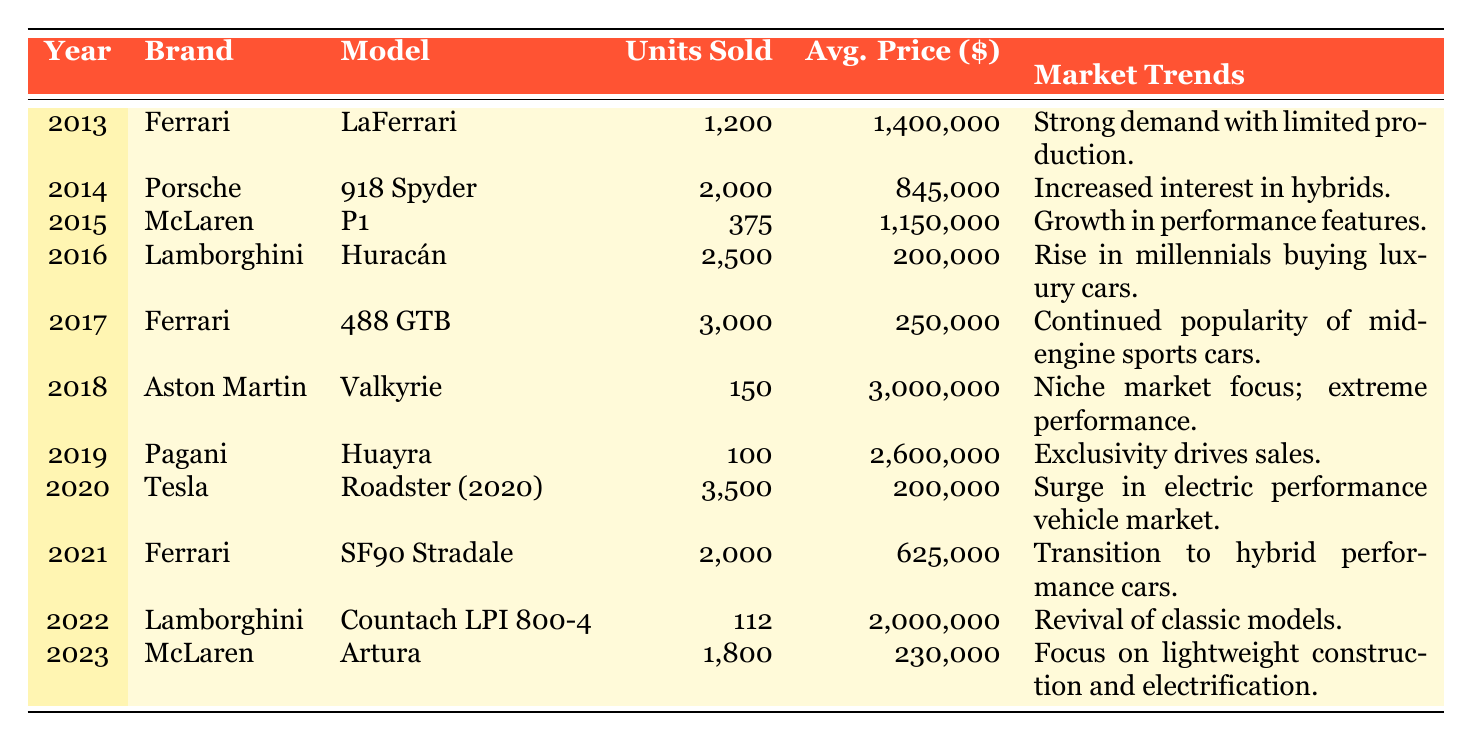What was the highest average price for a luxury sports car in the table? The highest average price is found in the row for the Aston Martin Valkyrie with an average price of 3,000,000. This can be confirmed by checking all average prices listed for each model.
Answer: 3,000,000 In which year did Ferrari sell the most units? Ferrari sold the most units in 2017 with 3,000 units sold for the 488 GTB model. We can find this by comparing the units sold for all Ferrari models listed in the table.
Answer: 2017 What is the total number of luxury sports cars sold by Lamborghini over the years listed? The total units sold by Lamborghini is 2,500 (Huracán in 2016) + 112 (Countach LPI 800-4 in 2022) = 2,612. We sum the units sold for both Lamborghini models to get the total.
Answer: 2,612 Did Tesla sell more units than Pagani in 2020 and 2019 combined? In 2020, Tesla sold 3,500 units (Roadster), while Pagani sold 100 units in 2019 (Huayra). Combining these gives us 3,500 for Tesla plus 100 for Pagani, which results in 3,600 units for Tesla, while Pagani sold only 100. Therefore, Tesla sold more units.
Answer: Yes What was the market trend for McLaren's Artura in 2023? The market trend for McLaren's Artura is described as focusing on lightweight construction and electrification. This is directly stated in the market trends column for that specific row.
Answer: Focus on lightweight construction and electrification Which brand had a stronger market trend, "strong demand with limited production" or "surge in electric performance vehicle market"? The brand Ferrari had the market trend "strong demand with limited production" in 2013. In comparison, Tesla's "surge in electric performance vehicle market" in 2020 indicates a boom in electric vehicles. To assess which was stronger, "strong demand" historically resulted in higher units sold for Ferrari (1,200) versus Tesla's (3,500) in 2020, suggesting that the trend with the highest units sold was stronger overall.
Answer: "Surge in electric performance vehicle market" is stronger What is the average number of units sold by Ferrari during the 2010s? Ferrari sold 1,200 (LaFerrari in 2013) + 3,000 (488 GTB in 2017) + 2,000 (SF90 Stradale in 2021), which totals to 6,200 units. The average over the three years is 6,200 divided by 3, resulting in approximately 2,066.7. The average is calculated by dividing the total units by the number of models sold.
Answer: Approximately 2,066.7 Was the number of units sold for Lamborghini's Countach LPI 800-4 in 2022 more than those sold for Pagani's Huayra in 2019? Lamborghini sold 112 units of the Countach LPI 800-4 in 2022, while Pagani sold only 100 units of the Huayra in 2019. Therefore, the units sold for Lamborghini in 2022 are indeed more than those sold by Pagani in 2019.
Answer: Yes 